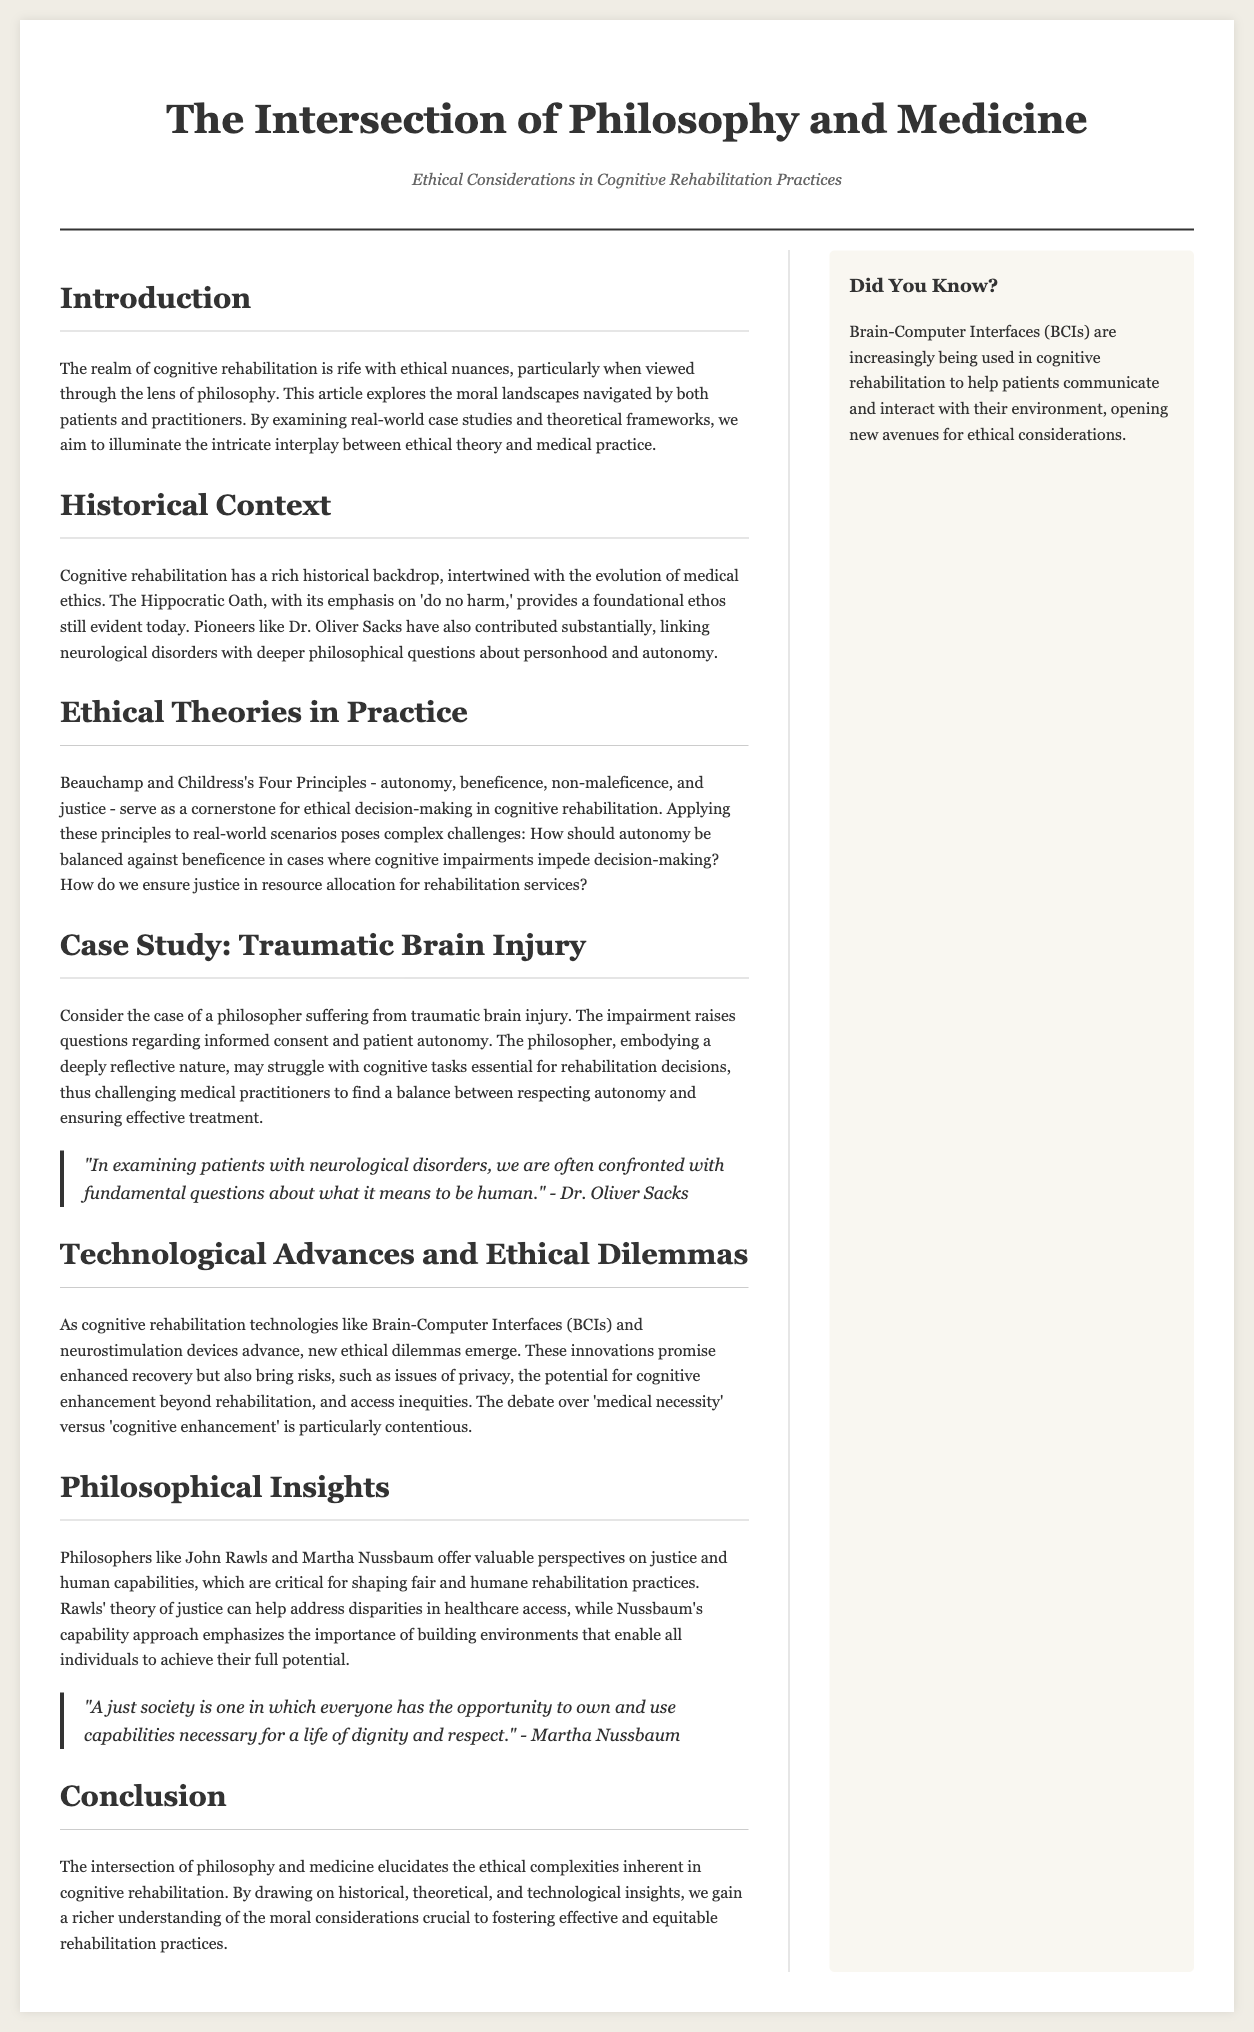What is the title of the article? The title of the article is provided in the header of the document, which is "The Intersection of Philosophy and Medicine."
Answer: The Intersection of Philosophy and Medicine Who is quoted regarding the examination of patients with neurological disorders? The quote discusses fundamental questions about humanity and is attributed to Dr. Oliver Sacks.
Answer: Dr. Oliver Sacks What ethical principle emphasizes 'do no harm'? The document discusses historical context, specifically mentioning the Hippocratic Oath as providing this foundational ethos.
Answer: Hippocratic Oath Which technologies are mentioned in the context of cognitive rehabilitation? The section on technological advances specifically mentions Brain-Computer Interfaces (BCIs) and neurostimulation devices.
Answer: Brain-Computer Interfaces (BCIs) What philosopher's theory of justice is mentioned in the document? John Rawls is mentioned in the context of providing valuable perspectives on justice and healthcare access.
Answer: John Rawls How does the document categorize ethical decision-making principles in cognitive rehabilitation? It states that Beauchamp and Childress's Four Principles guide ethical decisions, which include autonomy, beneficence, non-maleficence, and justice.
Answer: Four Principles What is described as increasingly being used in cognitive rehabilitation? The sidebar notes that Brain-Computer Interfaces (BCIs) are increasingly being used to help patients communicate and interact with their environment.
Answer: Brain-Computer Interfaces (BCIs) What phrase summarizes the conclusion of the document? The conclusion of the document encompasses the complex interplay of philosophy and medicine within cognitive rehabilitation ethics.
Answer: Ethical complexities What is highlighted as a contentious issue regarding cognitive enhancement? The document points out the debate over ‘medical necessity’ versus ‘cognitive enhancement’ as a particularly contentious topic.
Answer: Medical necessity vs cognitive enhancement 